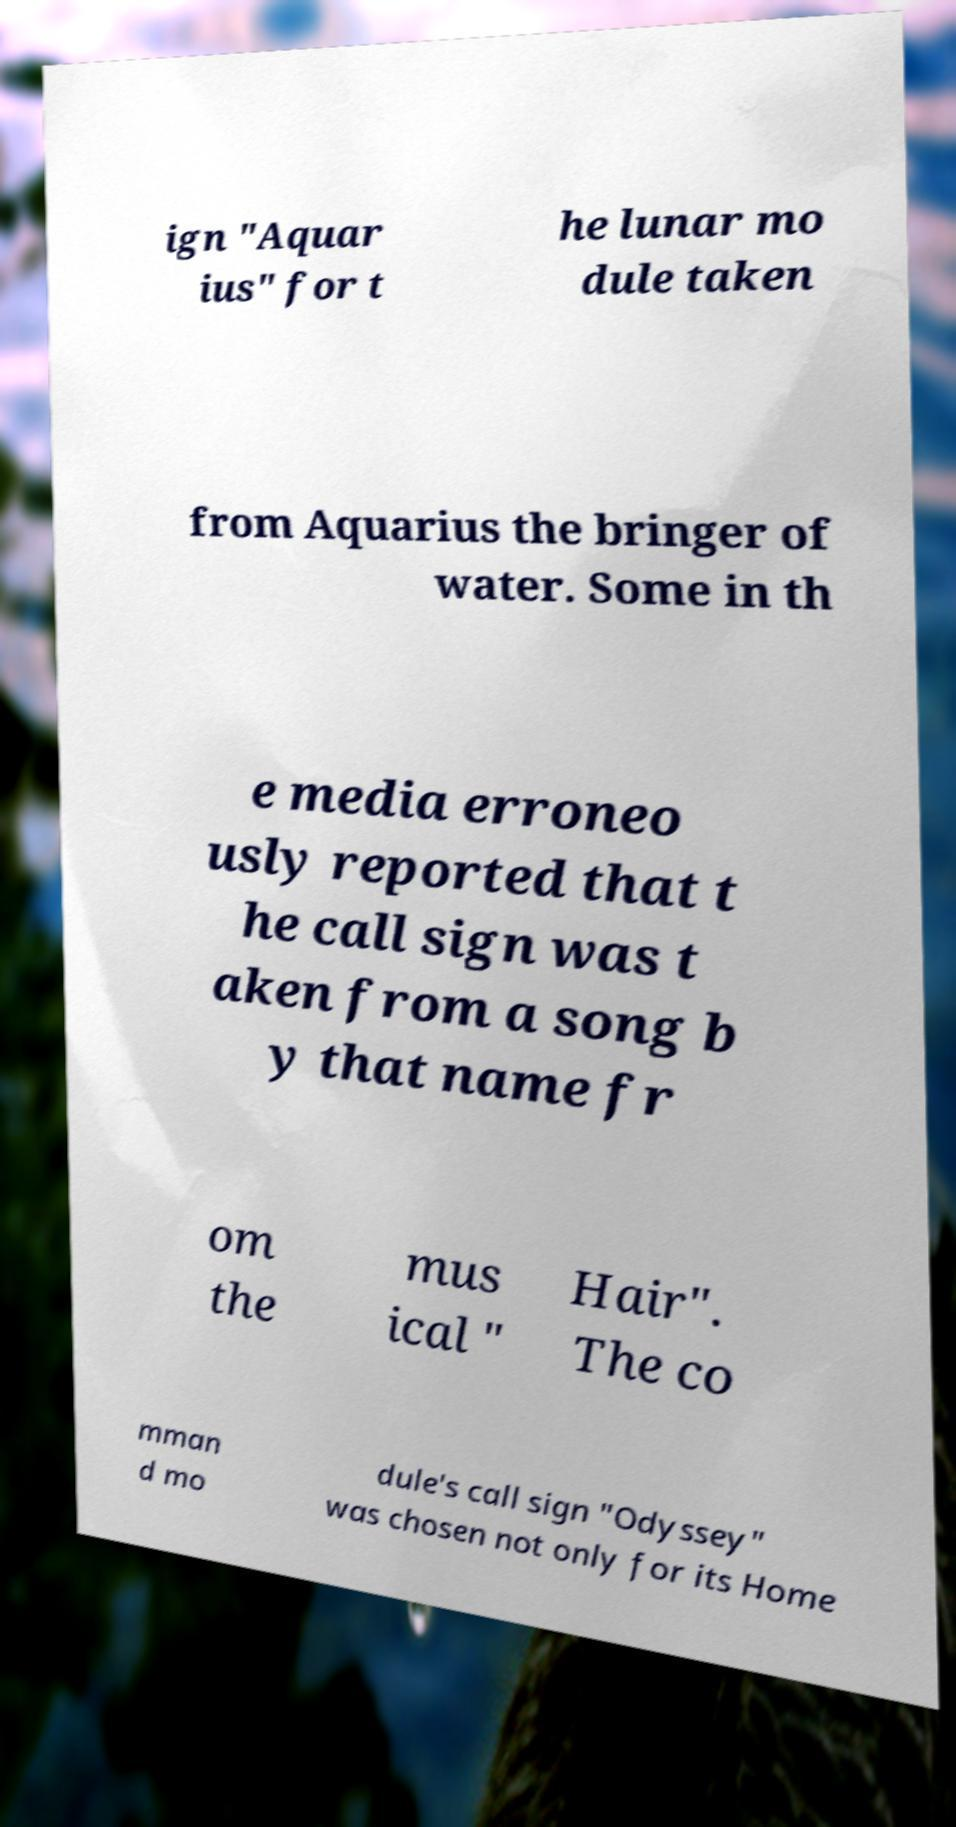Could you assist in decoding the text presented in this image and type it out clearly? ign "Aquar ius" for t he lunar mo dule taken from Aquarius the bringer of water. Some in th e media erroneo usly reported that t he call sign was t aken from a song b y that name fr om the mus ical " Hair". The co mman d mo dule's call sign "Odyssey" was chosen not only for its Home 